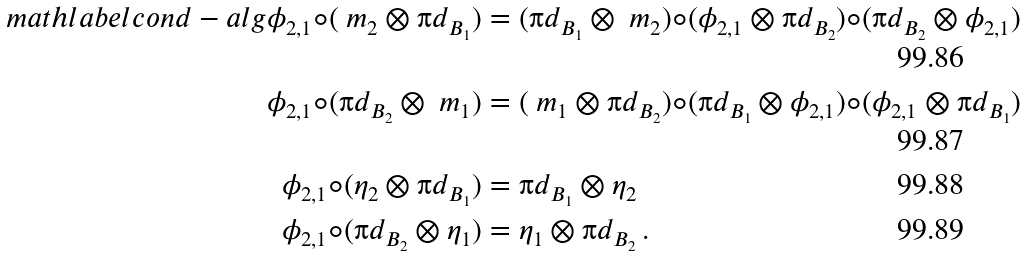<formula> <loc_0><loc_0><loc_500><loc_500>\ m a t h l a b e l { c o n d - a l g } \phi _ { 2 , 1 } \circ ( \ m _ { 2 } \otimes \i d _ { B _ { 1 } } ) & = ( \i d _ { B _ { 1 } } \otimes \ m _ { 2 } ) \circ ( \phi _ { 2 , 1 } \otimes \i d _ { B _ { 2 } } ) \circ ( \i d _ { B _ { 2 } } \otimes \phi _ { 2 , 1 } ) \, \\ \phi _ { 2 , 1 } \circ ( \i d _ { B _ { 2 } } \otimes \ m _ { 1 } ) & = ( \ m _ { 1 } \otimes \i d _ { B _ { 2 } } ) \circ ( \i d _ { B _ { 1 } } \otimes \phi _ { 2 , 1 } ) \circ ( \phi _ { 2 , 1 } \otimes \i d _ { B _ { 1 } } ) \, \\ \phi _ { 2 , 1 } \circ ( \eta _ { 2 } \otimes \i d _ { B _ { 1 } } ) & = \i d _ { B _ { 1 } } \otimes \eta _ { 2 } \, \\ \phi _ { 2 , 1 } \circ ( \i d _ { B _ { 2 } } \otimes \eta _ { 1 } ) & = \eta _ { 1 } \otimes \i d _ { B _ { 2 } } \, .</formula> 